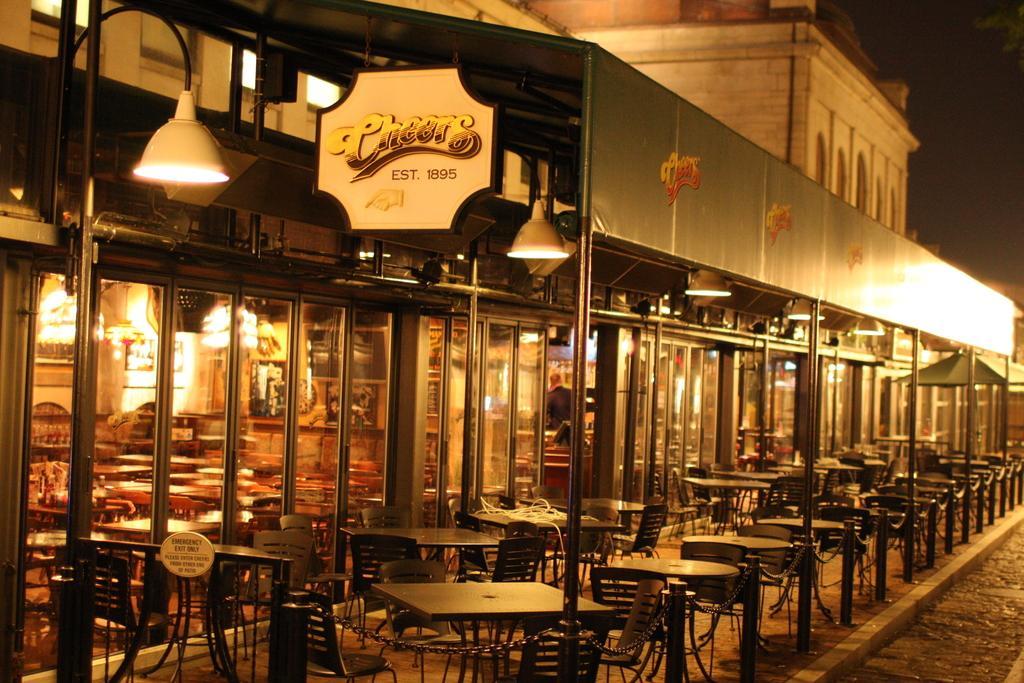Please provide a concise description of this image. In this image I can see the building , in front of the building I can see tables and chairs and I can see chairs and I can see a lamp attached to the wall of the building. 